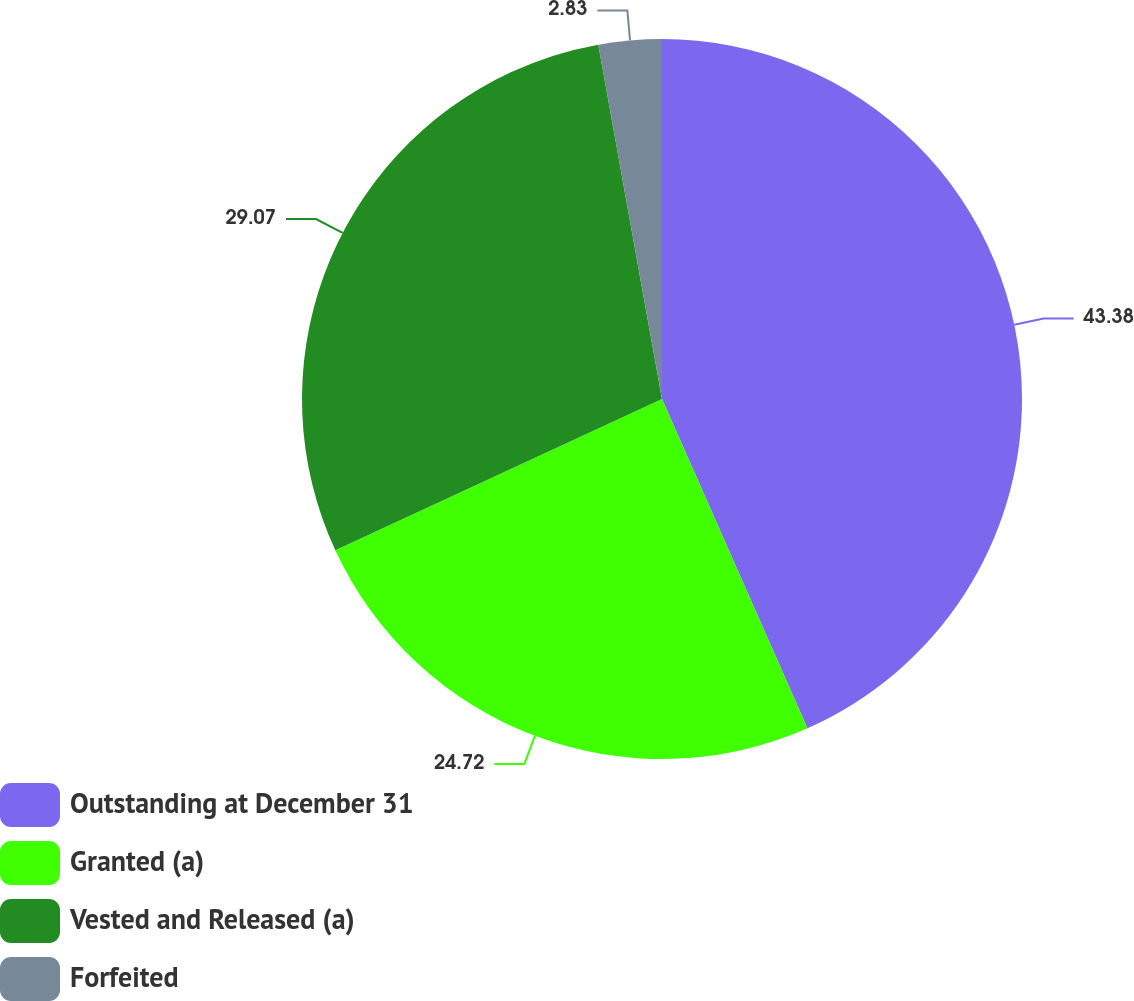Convert chart to OTSL. <chart><loc_0><loc_0><loc_500><loc_500><pie_chart><fcel>Outstanding at December 31<fcel>Granted (a)<fcel>Vested and Released (a)<fcel>Forfeited<nl><fcel>43.38%<fcel>24.72%<fcel>29.07%<fcel>2.83%<nl></chart> 